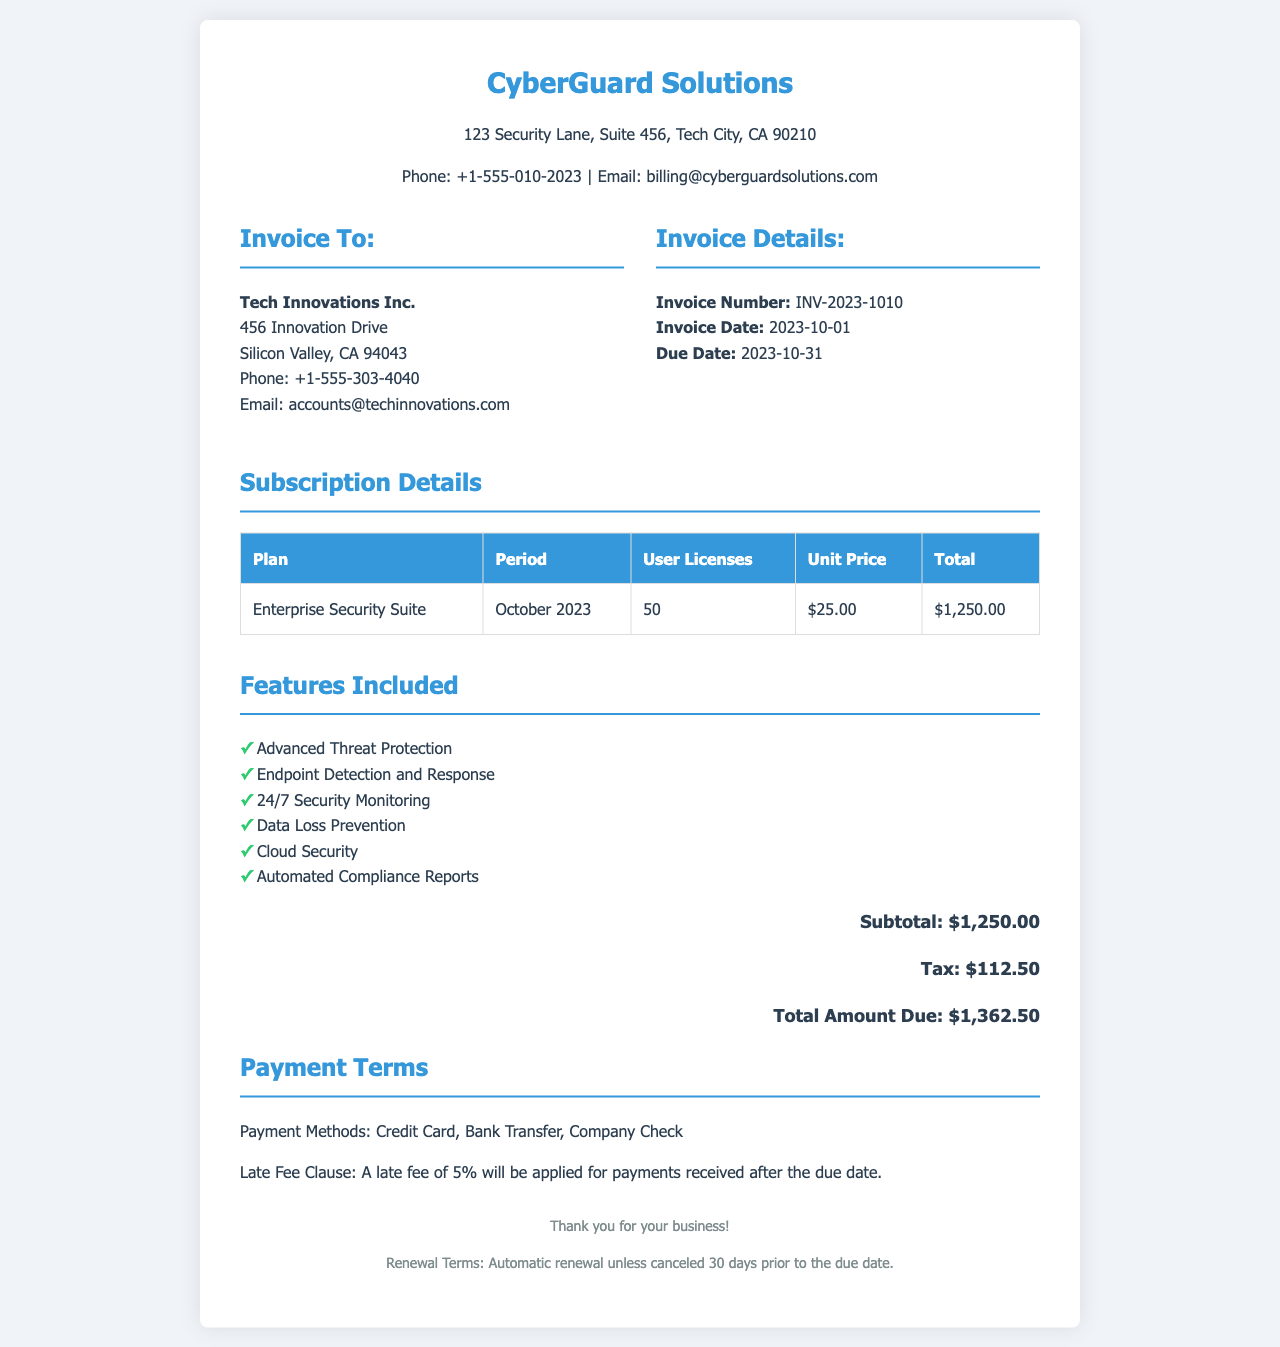What is the invoice number? The invoice number is a unique identifier for this billing document, which is INV-2023-1010.
Answer: INV-2023-1010 What is the total amount due? The total amount due is the final amount that needs to be paid as stated in the document, which is $1,362.50.
Answer: $1,362.50 How many user licenses are included? The number of user licenses refers to the counts specified in the subscription details, which is 50.
Answer: 50 What is the due date of the invoice? The due date indicates when the payment should be made, which is 2023-10-31.
Answer: 2023-10-31 What features are included in the subscription? The features listed provide additional services offered with the subscription, showing a variety of cybersecurity capabilities offered.
Answer: Advanced Threat Protection, Endpoint Detection and Response, 24/7 Security Monitoring, Data Loss Prevention, Cloud Security, Automated Compliance Reports What is the tax amount? The tax amount is an additional charge calculated based on the subtotal, stated to be $112.50.
Answer: $112.50 What are the payment methods accepted? This refers to the options provided for making payments, which includes multiple types typically used in business transactions.
Answer: Credit Card, Bank Transfer, Company Check What is the subtotal before tax? The subtotal represents the total amount prior to adding any tax, which is $1,250.00.
Answer: $1,250.00 What is the late fee clause? The late fee clause describes the penalty applied for overdue payments, specifically stating a percentage added to overdue balances.
Answer: A late fee of 5% will be applied for payments received after the due date What are the renewal terms for the subscription? The renewal terms indicate the conditions under which the subscription continues, specifically outlining the required notice period for cancellation.
Answer: Automatic renewal unless canceled 30 days prior to the due date 